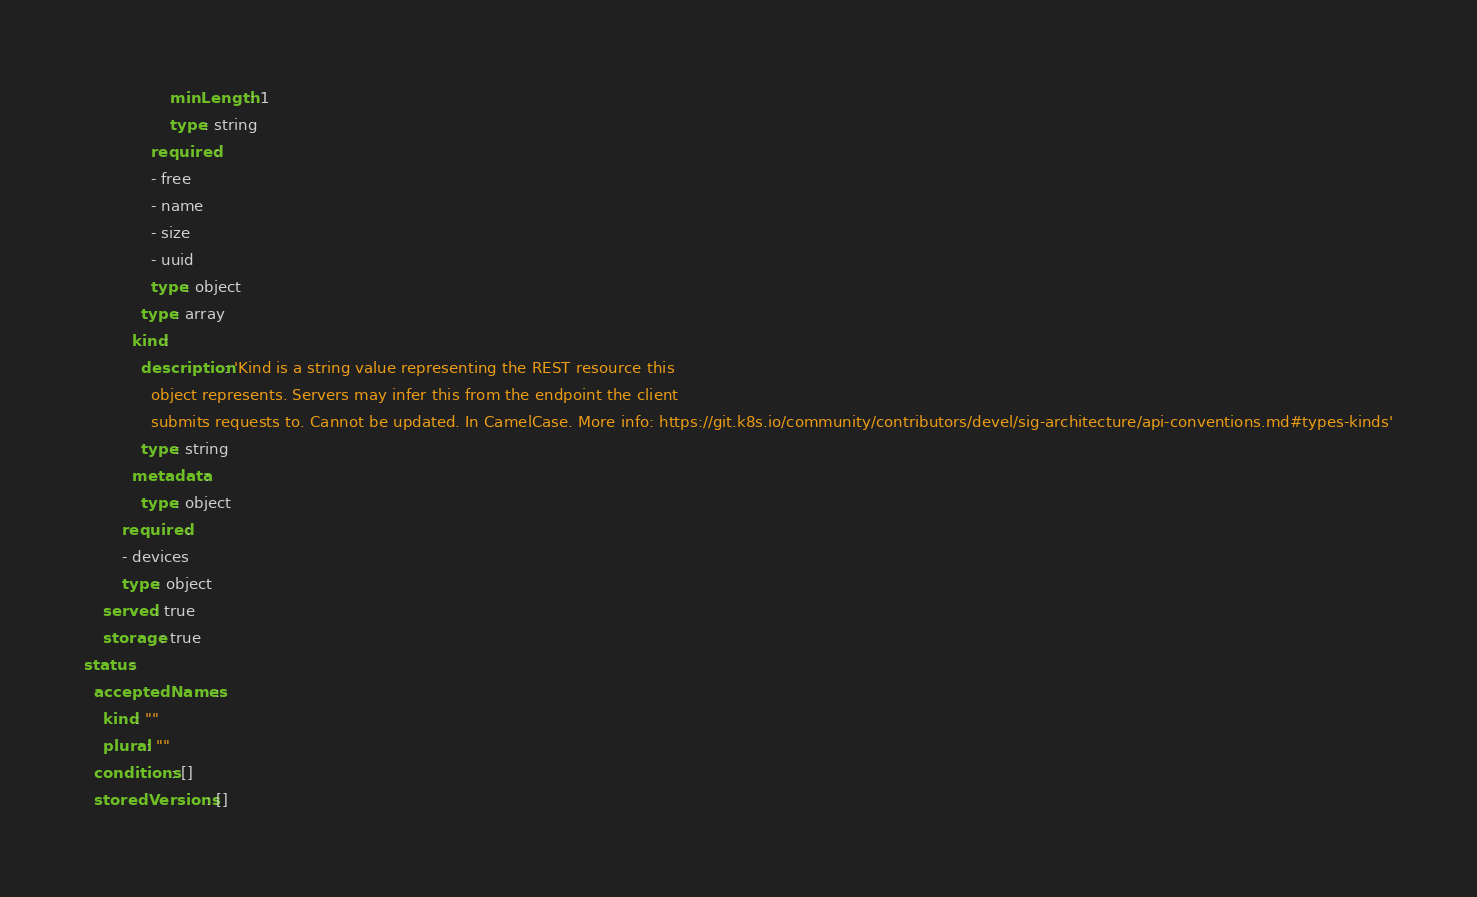<code> <loc_0><loc_0><loc_500><loc_500><_YAML_>                  minLength: 1
                  type: string
              required:
              - free
              - name
              - size
              - uuid
              type: object
            type: array
          kind:
            description: 'Kind is a string value representing the REST resource this
              object represents. Servers may infer this from the endpoint the client
              submits requests to. Cannot be updated. In CamelCase. More info: https://git.k8s.io/community/contributors/devel/sig-architecture/api-conventions.md#types-kinds'
            type: string
          metadata:
            type: object
        required:
        - devices
        type: object
    served: true
    storage: true
status:
  acceptedNames:
    kind: ""
    plural: ""
  conditions: []
  storedVersions: []
</code> 